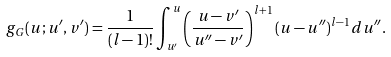Convert formula to latex. <formula><loc_0><loc_0><loc_500><loc_500>g _ { G } ( u ; u ^ { \prime } , v ^ { \prime } ) = \frac { 1 } { ( l - 1 ) ! } \int _ { u ^ { \prime } } ^ { u } \left ( \frac { u - v ^ { \prime } } { u ^ { \prime \prime } - v ^ { \prime } } \right ) ^ { l + 1 } ( u - u ^ { \prime \prime } ) ^ { l - 1 } d u ^ { \prime \prime } .</formula> 